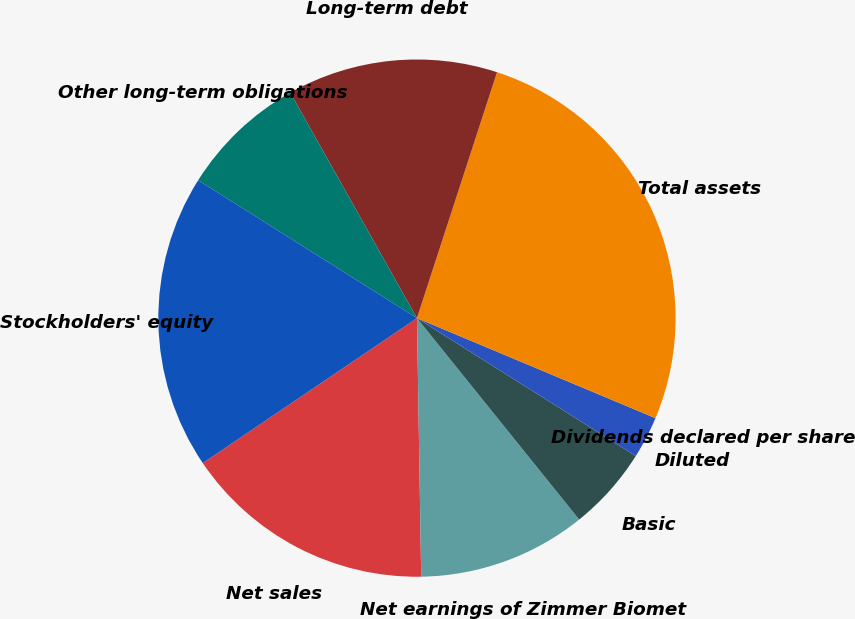<chart> <loc_0><loc_0><loc_500><loc_500><pie_chart><fcel>Net sales<fcel>Net earnings of Zimmer Biomet<fcel>Basic<fcel>Diluted<fcel>Dividends declared per share<fcel>Total assets<fcel>Long-term debt<fcel>Other long-term obligations<fcel>Stockholders' equity<nl><fcel>15.79%<fcel>10.53%<fcel>5.26%<fcel>2.63%<fcel>0.0%<fcel>26.31%<fcel>13.16%<fcel>7.9%<fcel>18.42%<nl></chart> 